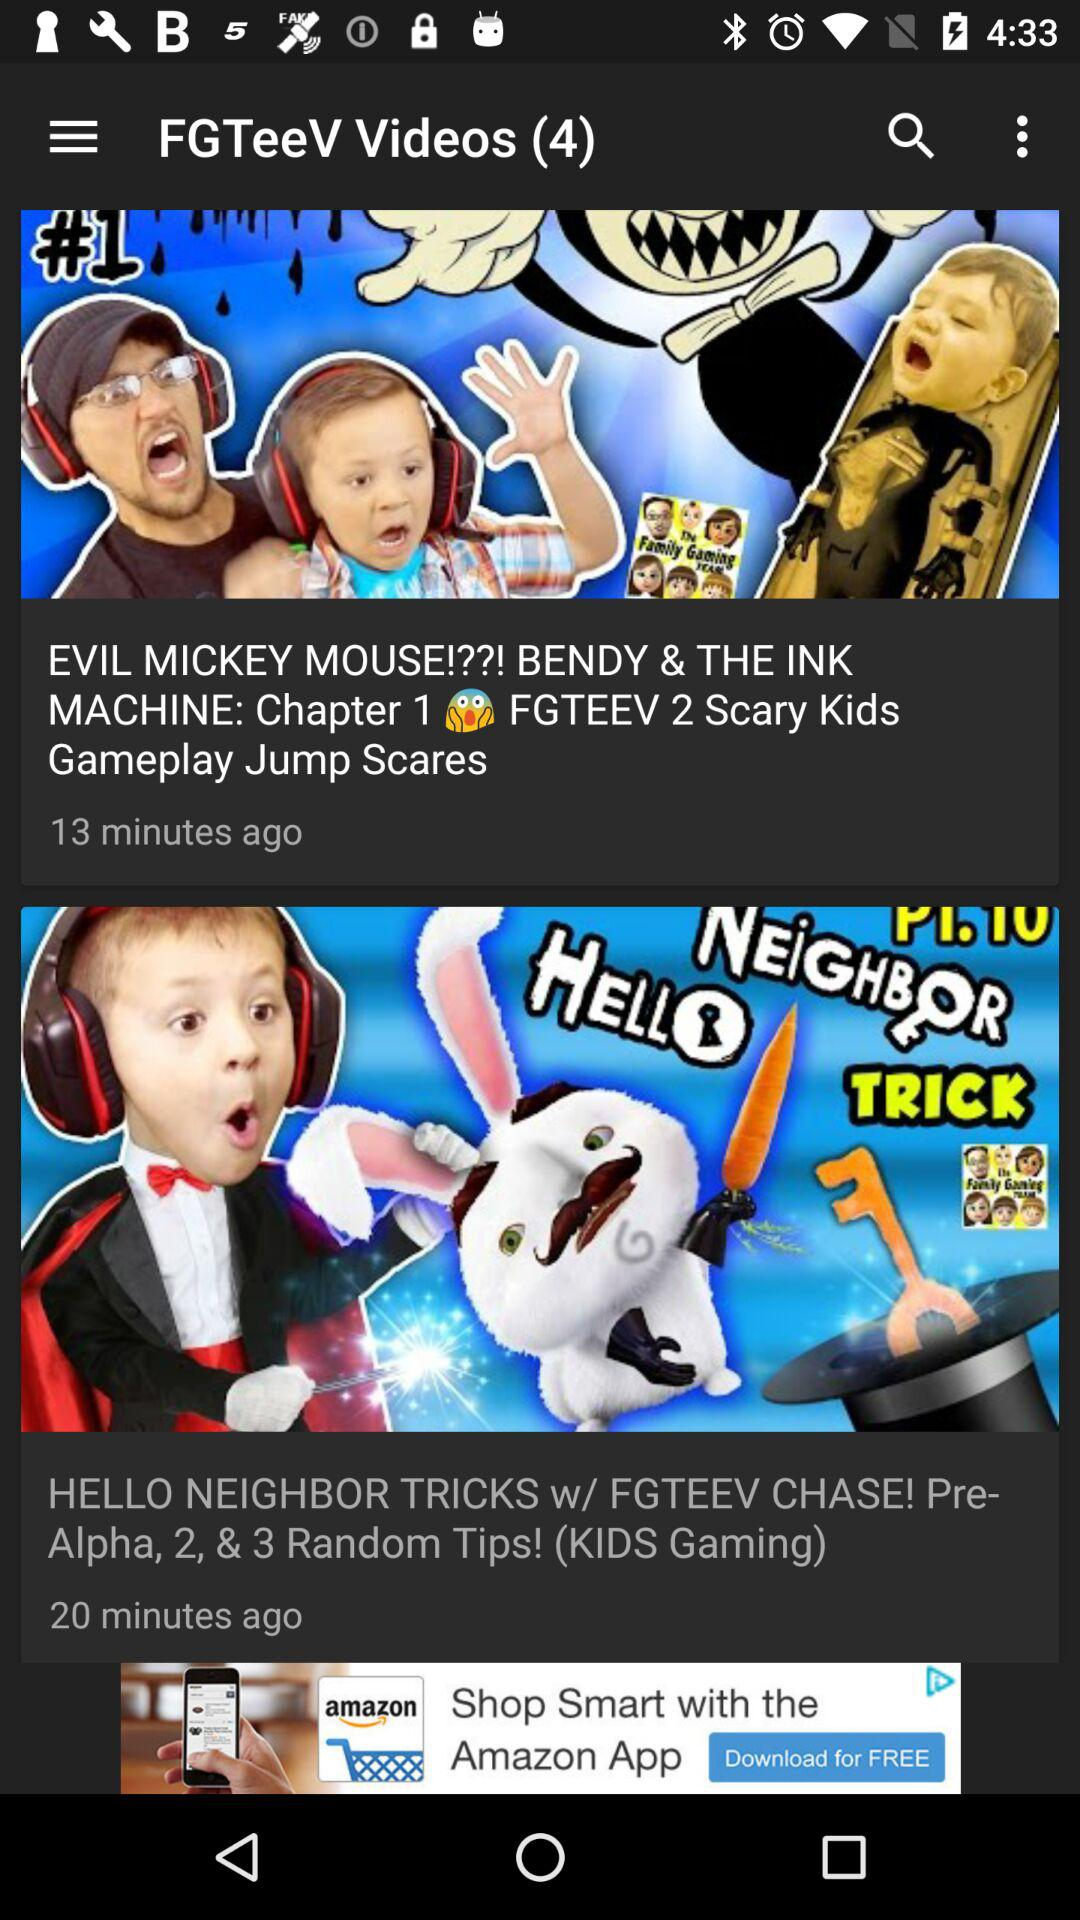What is the count of FGTeeV videos? There are four FGTeeV videos. 